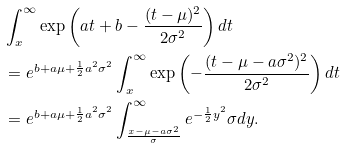<formula> <loc_0><loc_0><loc_500><loc_500>& \int _ { x } ^ { \infty } \exp \left ( a t + b - \frac { ( t - \mu ) ^ { 2 } } { 2 \sigma ^ { 2 } } \right ) d t \\ & = e ^ { b + a \mu + \frac { 1 } { 2 } a ^ { 2 } \sigma ^ { 2 } } \int _ { x } ^ { \infty } \exp \left ( - \frac { ( t - \mu - a \sigma ^ { 2 } ) ^ { 2 } } { 2 \sigma ^ { 2 } } \right ) d t \\ & = e ^ { b + a \mu + \frac { 1 } { 2 } a ^ { 2 } \sigma ^ { 2 } } \int _ { \frac { x - \mu - a \sigma ^ { 2 } } { \sigma } } ^ { \infty } e ^ { - \frac { 1 } { 2 } y ^ { 2 } } \sigma d y .</formula> 